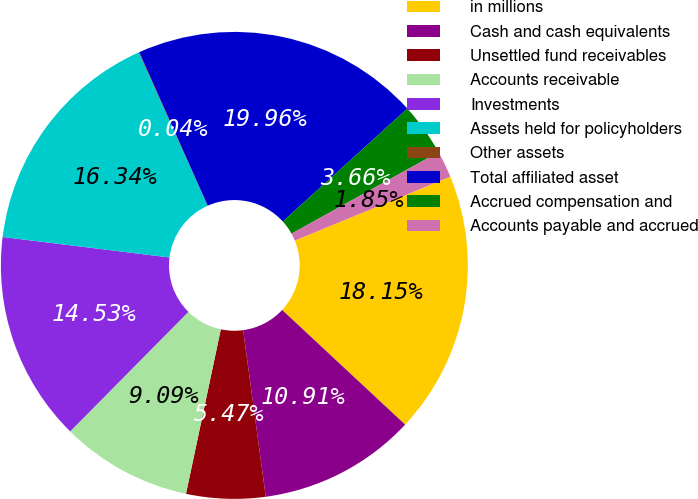Convert chart to OTSL. <chart><loc_0><loc_0><loc_500><loc_500><pie_chart><fcel>in millions<fcel>Cash and cash equivalents<fcel>Unsettled fund receivables<fcel>Accounts receivable<fcel>Investments<fcel>Assets held for policyholders<fcel>Other assets<fcel>Total affiliated asset<fcel>Accrued compensation and<fcel>Accounts payable and accrued<nl><fcel>18.15%<fcel>10.91%<fcel>5.47%<fcel>9.09%<fcel>14.53%<fcel>16.34%<fcel>0.04%<fcel>19.96%<fcel>3.66%<fcel>1.85%<nl></chart> 